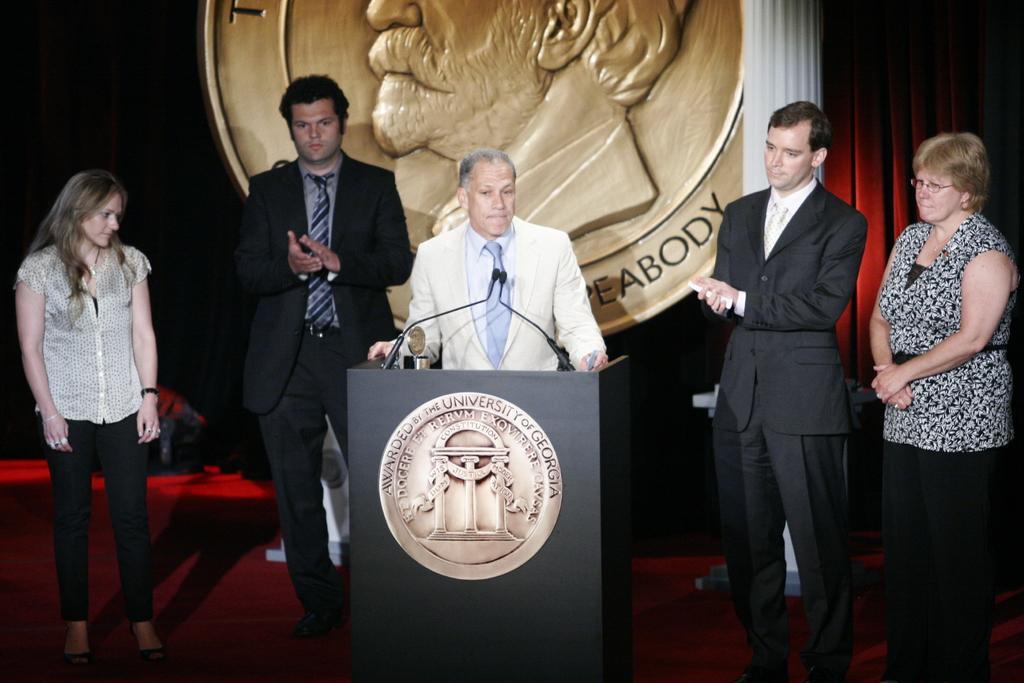Could you give a brief overview of what you see in this image? This image consists of five persons. In the front, the man wearing a white suit is standing near the podium. On the left and right, there are women. Beside the podium, there are two men wearing black suits are standing. In the background, there is a metal batch. At the bottom, the mat is in red color. 